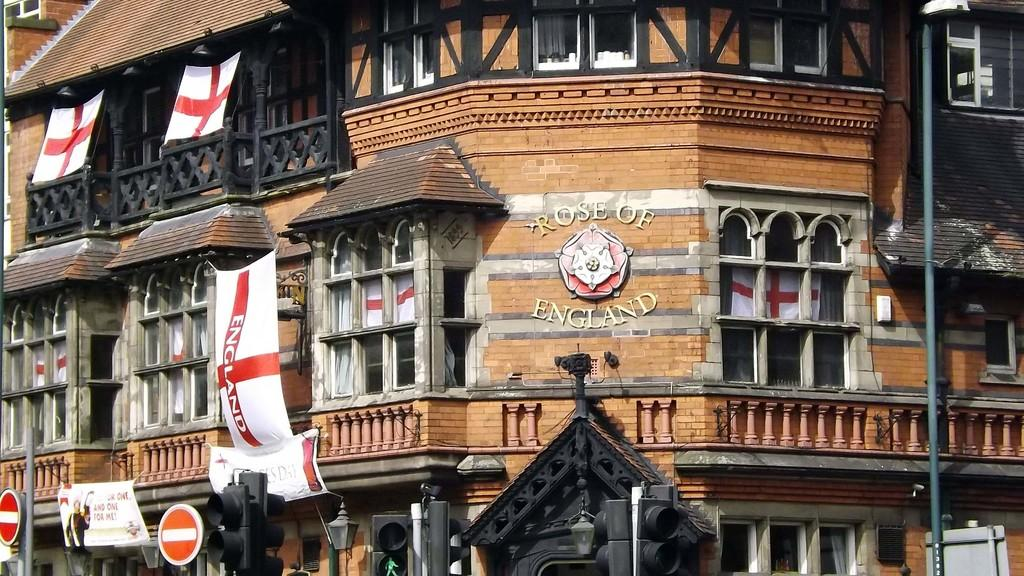<image>
Relay a brief, clear account of the picture shown. The sign for the Rose of England has a rose right in the center. 